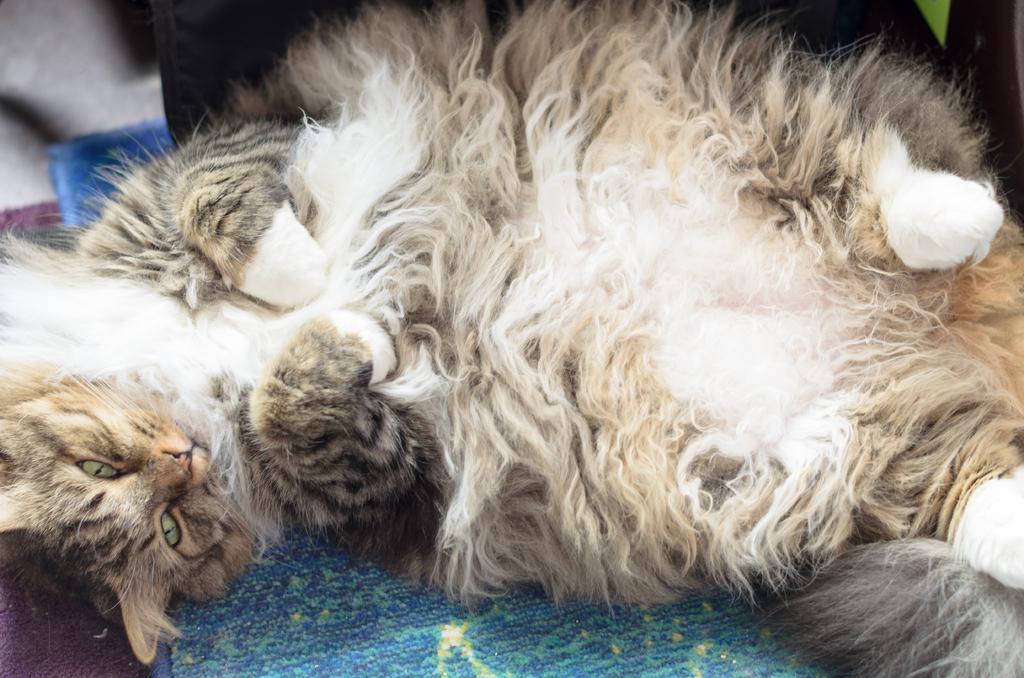Can you describe this image briefly? In this picture we can see a cloth is laying on the cloth. 